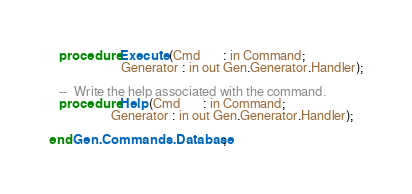<code> <loc_0><loc_0><loc_500><loc_500><_Ada_>   procedure Execute (Cmd       : in Command;
                      Generator : in out Gen.Generator.Handler);

   --  Write the help associated with the command.
   procedure Help (Cmd       : in Command;
                   Generator : in out Gen.Generator.Handler);

end Gen.Commands.Database;
</code> 